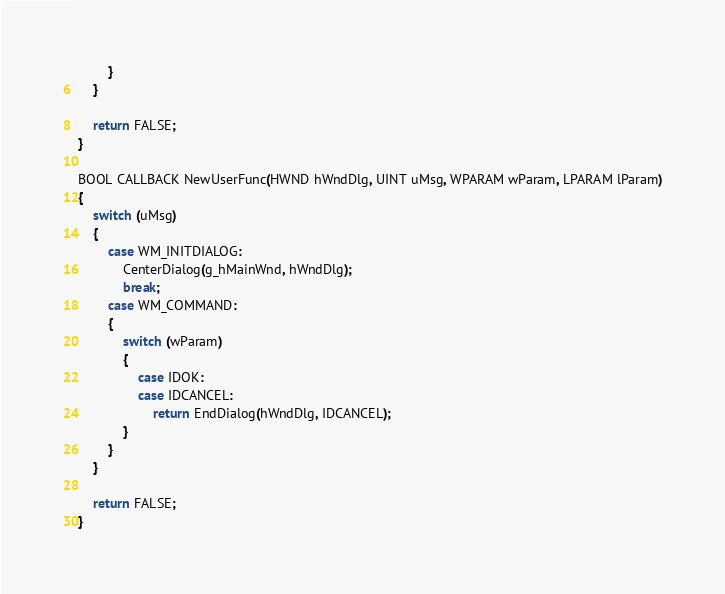Convert code to text. <code><loc_0><loc_0><loc_500><loc_500><_C++_>		}
	}

	return FALSE;
}

BOOL CALLBACK NewUserFunc(HWND hWndDlg, UINT uMsg, WPARAM wParam, LPARAM lParam)
{
	switch (uMsg)
	{
		case WM_INITDIALOG:
			CenterDialog(g_hMainWnd, hWndDlg);
			break;
		case WM_COMMAND:
		{
			switch (wParam)
			{
				case IDOK:
				case IDCANCEL:
					return EndDialog(hWndDlg, IDCANCEL);
			}
		}
	}

	return FALSE;
}
</code> 